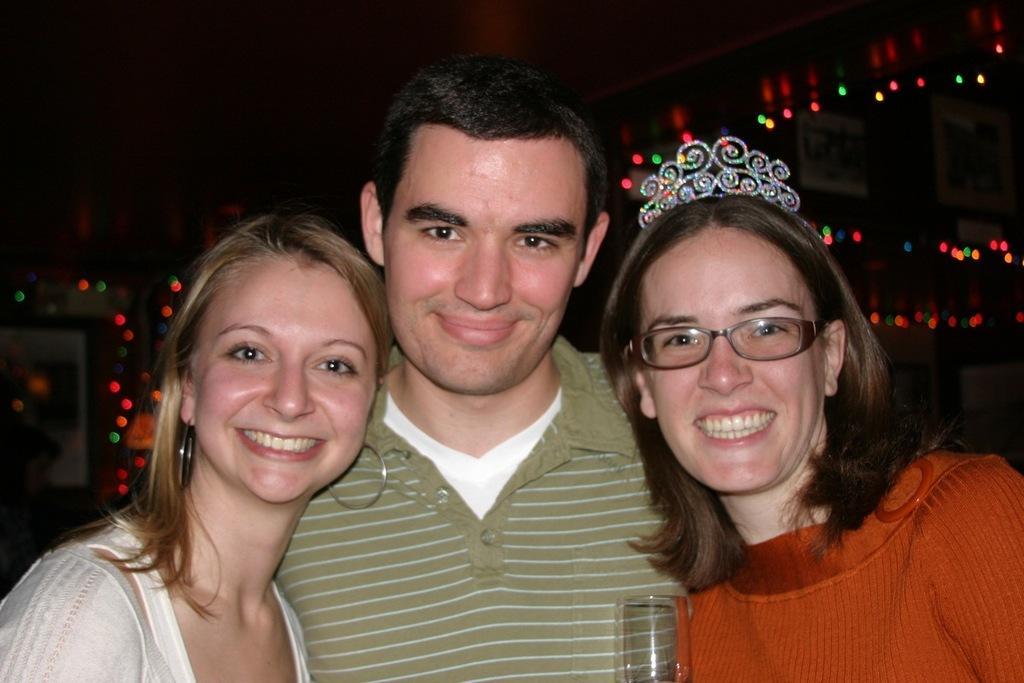How would you summarize this image in a sentence or two? In this image I can see three persons standing. The person at right wearing red color shirt, the person in the middle wearing white and gray color dress and the person at left wearing white color dress. I can see few lights and I can see dark background. 